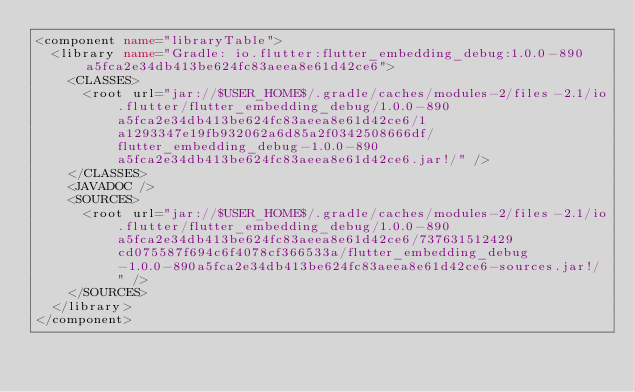<code> <loc_0><loc_0><loc_500><loc_500><_XML_><component name="libraryTable">
  <library name="Gradle: io.flutter:flutter_embedding_debug:1.0.0-890a5fca2e34db413be624fc83aeea8e61d42ce6">
    <CLASSES>
      <root url="jar://$USER_HOME$/.gradle/caches/modules-2/files-2.1/io.flutter/flutter_embedding_debug/1.0.0-890a5fca2e34db413be624fc83aeea8e61d42ce6/1a1293347e19fb932062a6d85a2f0342508666df/flutter_embedding_debug-1.0.0-890a5fca2e34db413be624fc83aeea8e61d42ce6.jar!/" />
    </CLASSES>
    <JAVADOC />
    <SOURCES>
      <root url="jar://$USER_HOME$/.gradle/caches/modules-2/files-2.1/io.flutter/flutter_embedding_debug/1.0.0-890a5fca2e34db413be624fc83aeea8e61d42ce6/737631512429cd075587f694c6f4078cf366533a/flutter_embedding_debug-1.0.0-890a5fca2e34db413be624fc83aeea8e61d42ce6-sources.jar!/" />
    </SOURCES>
  </library>
</component></code> 